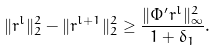Convert formula to latex. <formula><loc_0><loc_0><loc_500><loc_500>\| r ^ { l } \| _ { 2 } ^ { 2 } - \| r ^ { l + 1 } \| _ { 2 } ^ { 2 } \geq \frac { \| \Phi ^ { \prime } r ^ { l } \| _ { \infty } ^ { 2 } } { 1 + \delta _ { 1 } } .</formula> 